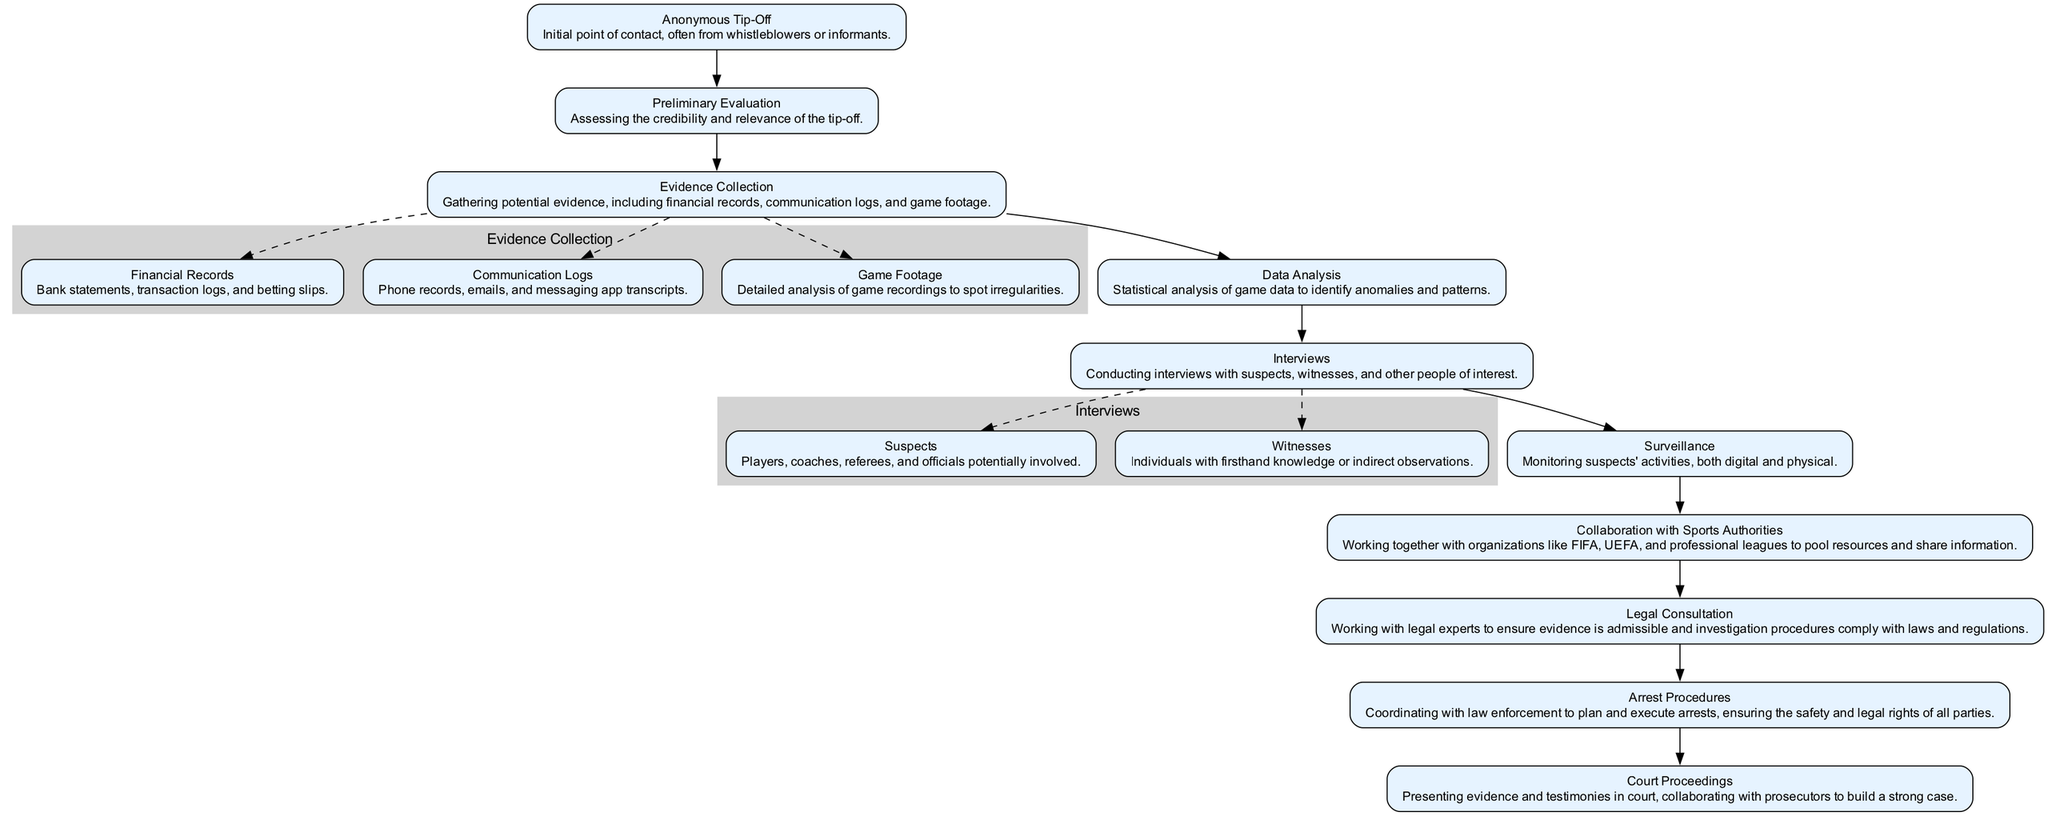What is the initial point of contact in the investigation workflow? The diagram specifies "Anonymous Tip-Off" as the starting element of the workflow, indicating that the investigation begins with information provided by whistleblowers or informants.
Answer: Anonymous Tip-Off How many main elements are in the workflow diagram? By closely examining the elements listed in the diagram, we find that there are nine main elements in the workflow process.
Answer: Nine What follows after Preliminary Evaluation in the investigation workflow? The arrow connecting "Preliminary Evaluation" to the next node visually indicates that "Evidence Collection" follows as the next step in the process.
Answer: Evidence Collection Which node involves monitoring suspects’ activities? "Surveillance" is the specific node mentioned in the diagram that details the activity of monitoring suspects in relation to the investigation.
Answer: Surveillance How many subelements are under Evidence Collection? The diagram indicates that there are three subelements listed under "Evidence Collection," namely Financial Records, Communication Logs, and Game Footage.
Answer: Three Which node culminates in presenting evidence in court? The final part of the workflow is represented by the "Court Proceedings" node, where evidence and testimonies are presented to the court.
Answer: Court Proceedings What is the relationship between Legal Consultation and Arrest Procedures? The diagram does not depict a direct connection between "Legal Consultation" and "Arrest Procedures," but they are both crucial stages of the investigation. Legal consultation ensures evidence is admissible before any arrests are made.
Answer: No direct connection Which element involves collaboration with organizations like FIFA and UEFA? The element titled "Collaboration with Sports Authorities" specifically addresses the partnerships formed with organizations such as FIFA and UEFA within the investigation.
Answer: Collaboration with Sports Authorities Which nodes involve interviewing individuals? "Interviews" consists of subelements labeled "Suspects" and "Witnesses," indicating that this node includes questioning both suspects and individuals who may provide relevant information.
Answer: Interviews 